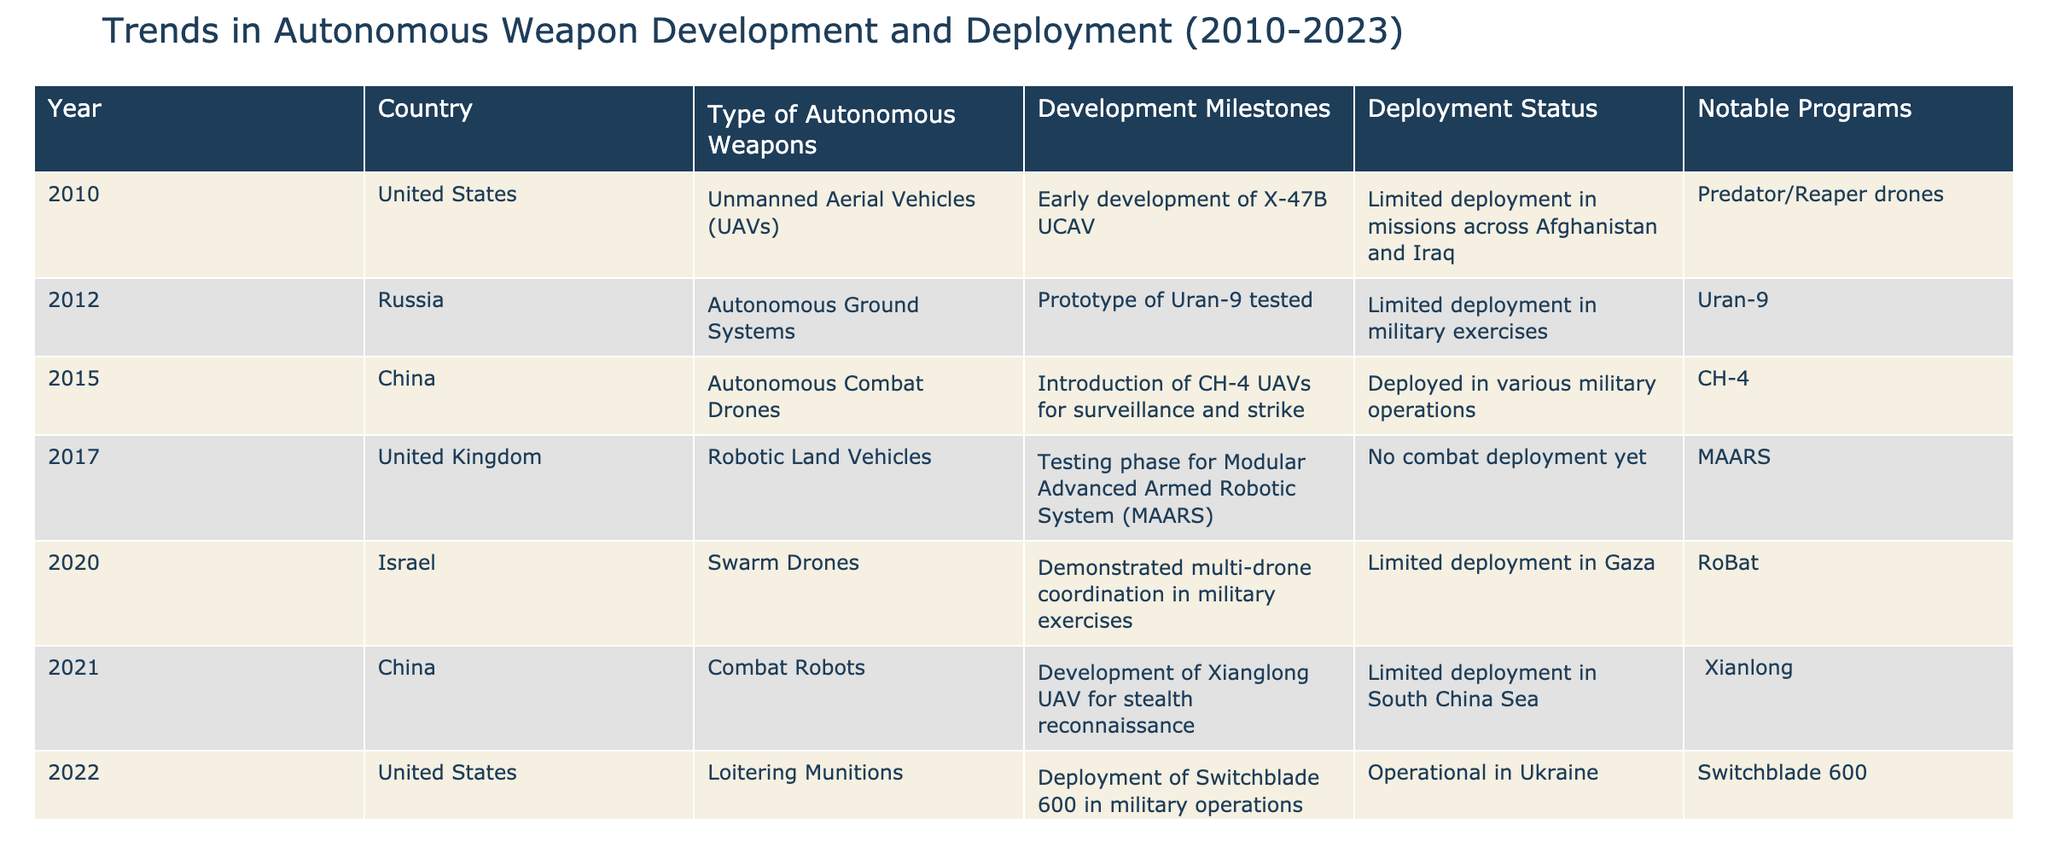What autonomous weapons were developed by the United States in 2022? In 2022, the United States developed Loitering Munitions, specifically deploying the Switchblade 600 in military operations.
Answer: Switchblade 600 Which country's autonomous combat drones were introduced in 2015? In 2015, China's Autonomous Combat Drones, specifically the CH-4 UAVs, were introduced for surveillance and strike.
Answer: China How many countries had limited deployment status for their autonomous weapons by 2023? By 2023, there were four countries (United States, Russia, China, and Israel) listed with limited deployment status, signaling that not all systems were fully operational in combat.
Answer: 4 Did the United Kingdom have any combat deployment of its robotic land vehicles by 2017? The table indicates that the United Kingdom's Modular Advanced Armed Robotic System (MAARS) was in the testing phase with no combat deployment yet.
Answer: No Which military power tested an autonomous ground system in military exercises? Russia tested the prototype of the Uran-9 autonomous ground system in military exercises, indicating an engagement with new technology in a controlled setting.
Answer: Russia What is the notable program associated with India's testing of autonomous battle tanks in 2023? India's testing of the K9 Vajra autonomous battle tank is highlighted as the notable program, emphasizing its focus on advanced military capabilities.
Answer: K9 Vajra What year saw the most significant introduction of a new type of autonomous weapon by China? The introduction of the CH-4 UAVs in 2015 marked the significant entry of a new type of autonomous weapon, specifically designed for combat roles in surveillance and strike missions.
Answer: 2015 Which country has shown the most rapid transition from development to deployment of autonomous weapons in the period from 2010 to 2023? The United States transitioned rapidly from development with the X-47B UCAV to deployment with the Switchblade 600, highlighting an aggressive advancement in integrating autonomous technology into military operations.
Answer: United States In what year did Israel demonstrate multi-drone coordination with swarm drones? Israel demonstrated multi-drone coordination with swarm drones in 2020, showcasing advancements in technology that allow for enhanced tactical flexibility in military operations.
Answer: 2020 